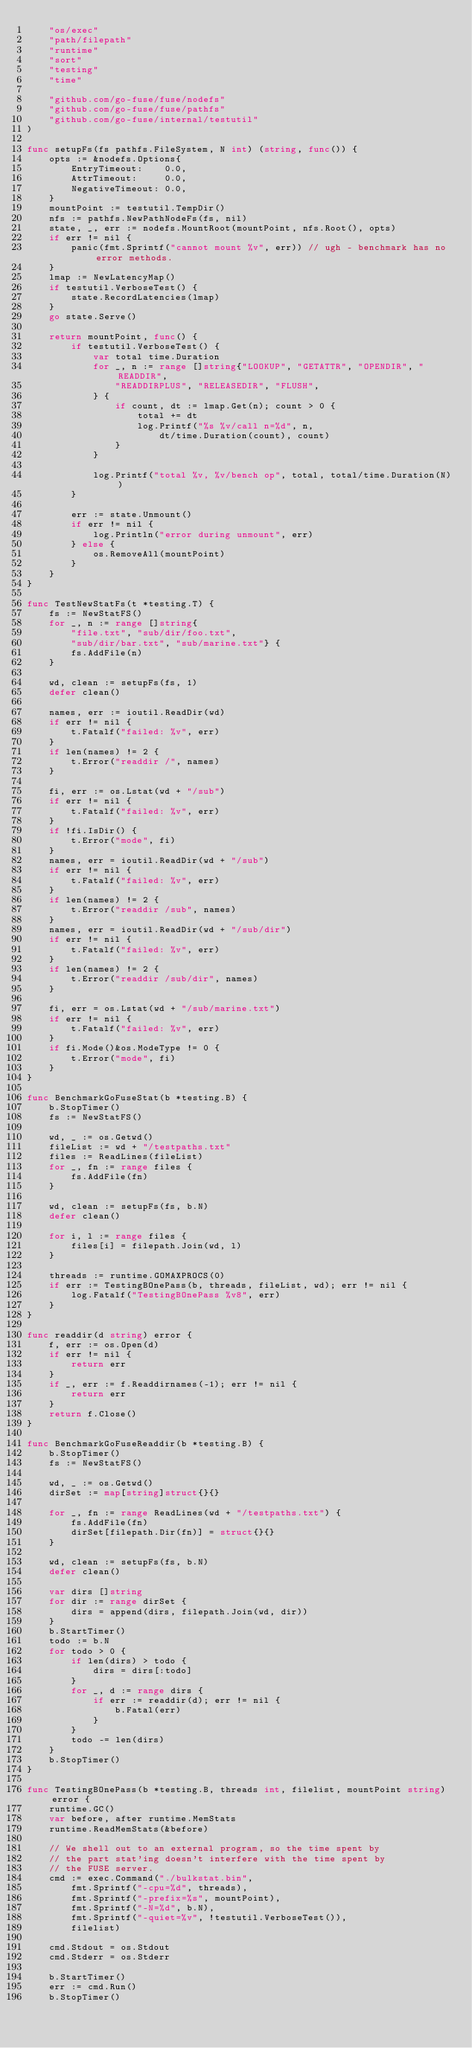<code> <loc_0><loc_0><loc_500><loc_500><_Go_>	"os/exec"
	"path/filepath"
	"runtime"
	"sort"
	"testing"
	"time"

	"github.com/go-fuse/fuse/nodefs"
	"github.com/go-fuse/fuse/pathfs"
	"github.com/go-fuse/internal/testutil"
)

func setupFs(fs pathfs.FileSystem, N int) (string, func()) {
	opts := &nodefs.Options{
		EntryTimeout:    0.0,
		AttrTimeout:     0.0,
		NegativeTimeout: 0.0,
	}
	mountPoint := testutil.TempDir()
	nfs := pathfs.NewPathNodeFs(fs, nil)
	state, _, err := nodefs.MountRoot(mountPoint, nfs.Root(), opts)
	if err != nil {
		panic(fmt.Sprintf("cannot mount %v", err)) // ugh - benchmark has no error methods.
	}
	lmap := NewLatencyMap()
	if testutil.VerboseTest() {
		state.RecordLatencies(lmap)
	}
	go state.Serve()

	return mountPoint, func() {
		if testutil.VerboseTest() {
			var total time.Duration
			for _, n := range []string{"LOOKUP", "GETATTR", "OPENDIR", "READDIR",
				"READDIRPLUS", "RELEASEDIR", "FLUSH",
			} {
				if count, dt := lmap.Get(n); count > 0 {
					total += dt
					log.Printf("%s %v/call n=%d", n,
						dt/time.Duration(count), count)
				}
			}

			log.Printf("total %v, %v/bench op", total, total/time.Duration(N))
		}

		err := state.Unmount()
		if err != nil {
			log.Println("error during unmount", err)
		} else {
			os.RemoveAll(mountPoint)
		}
	}
}

func TestNewStatFs(t *testing.T) {
	fs := NewStatFS()
	for _, n := range []string{
		"file.txt", "sub/dir/foo.txt",
		"sub/dir/bar.txt", "sub/marine.txt"} {
		fs.AddFile(n)
	}

	wd, clean := setupFs(fs, 1)
	defer clean()

	names, err := ioutil.ReadDir(wd)
	if err != nil {
		t.Fatalf("failed: %v", err)
	}
	if len(names) != 2 {
		t.Error("readdir /", names)
	}

	fi, err := os.Lstat(wd + "/sub")
	if err != nil {
		t.Fatalf("failed: %v", err)
	}
	if !fi.IsDir() {
		t.Error("mode", fi)
	}
	names, err = ioutil.ReadDir(wd + "/sub")
	if err != nil {
		t.Fatalf("failed: %v", err)
	}
	if len(names) != 2 {
		t.Error("readdir /sub", names)
	}
	names, err = ioutil.ReadDir(wd + "/sub/dir")
	if err != nil {
		t.Fatalf("failed: %v", err)
	}
	if len(names) != 2 {
		t.Error("readdir /sub/dir", names)
	}

	fi, err = os.Lstat(wd + "/sub/marine.txt")
	if err != nil {
		t.Fatalf("failed: %v", err)
	}
	if fi.Mode()&os.ModeType != 0 {
		t.Error("mode", fi)
	}
}

func BenchmarkGoFuseStat(b *testing.B) {
	b.StopTimer()
	fs := NewStatFS()

	wd, _ := os.Getwd()
	fileList := wd + "/testpaths.txt"
	files := ReadLines(fileList)
	for _, fn := range files {
		fs.AddFile(fn)
	}

	wd, clean := setupFs(fs, b.N)
	defer clean()

	for i, l := range files {
		files[i] = filepath.Join(wd, l)
	}

	threads := runtime.GOMAXPROCS(0)
	if err := TestingBOnePass(b, threads, fileList, wd); err != nil {
		log.Fatalf("TestingBOnePass %v8", err)
	}
}

func readdir(d string) error {
	f, err := os.Open(d)
	if err != nil {
		return err
	}
	if _, err := f.Readdirnames(-1); err != nil {
		return err
	}
	return f.Close()
}

func BenchmarkGoFuseReaddir(b *testing.B) {
	b.StopTimer()
	fs := NewStatFS()

	wd, _ := os.Getwd()
	dirSet := map[string]struct{}{}

	for _, fn := range ReadLines(wd + "/testpaths.txt") {
		fs.AddFile(fn)
		dirSet[filepath.Dir(fn)] = struct{}{}
	}

	wd, clean := setupFs(fs, b.N)
	defer clean()

	var dirs []string
	for dir := range dirSet {
		dirs = append(dirs, filepath.Join(wd, dir))
	}
	b.StartTimer()
	todo := b.N
	for todo > 0 {
		if len(dirs) > todo {
			dirs = dirs[:todo]
		}
		for _, d := range dirs {
			if err := readdir(d); err != nil {
				b.Fatal(err)
			}
		}
		todo -= len(dirs)
	}
	b.StopTimer()
}

func TestingBOnePass(b *testing.B, threads int, filelist, mountPoint string) error {
	runtime.GC()
	var before, after runtime.MemStats
	runtime.ReadMemStats(&before)

	// We shell out to an external program, so the time spent by
	// the part stat'ing doesn't interfere with the time spent by
	// the FUSE server.
	cmd := exec.Command("./bulkstat.bin",
		fmt.Sprintf("-cpu=%d", threads),
		fmt.Sprintf("-prefix=%s", mountPoint),
		fmt.Sprintf("-N=%d", b.N),
		fmt.Sprintf("-quiet=%v", !testutil.VerboseTest()),
		filelist)

	cmd.Stdout = os.Stdout
	cmd.Stderr = os.Stderr

	b.StartTimer()
	err := cmd.Run()
	b.StopTimer()</code> 